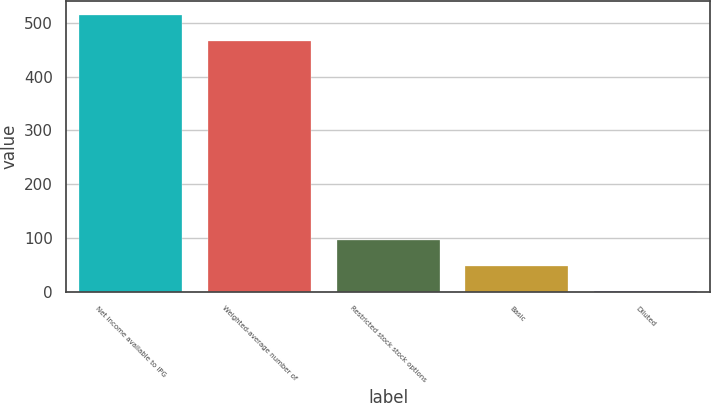Convert chart. <chart><loc_0><loc_0><loc_500><loc_500><bar_chart><fcel>Net income available to IPG<fcel>Weighted-average number of<fcel>Restricted stock stock options<fcel>Basic<fcel>Diluted<nl><fcel>514.4<fcel>466.8<fcel>96.32<fcel>48.72<fcel>1.12<nl></chart> 